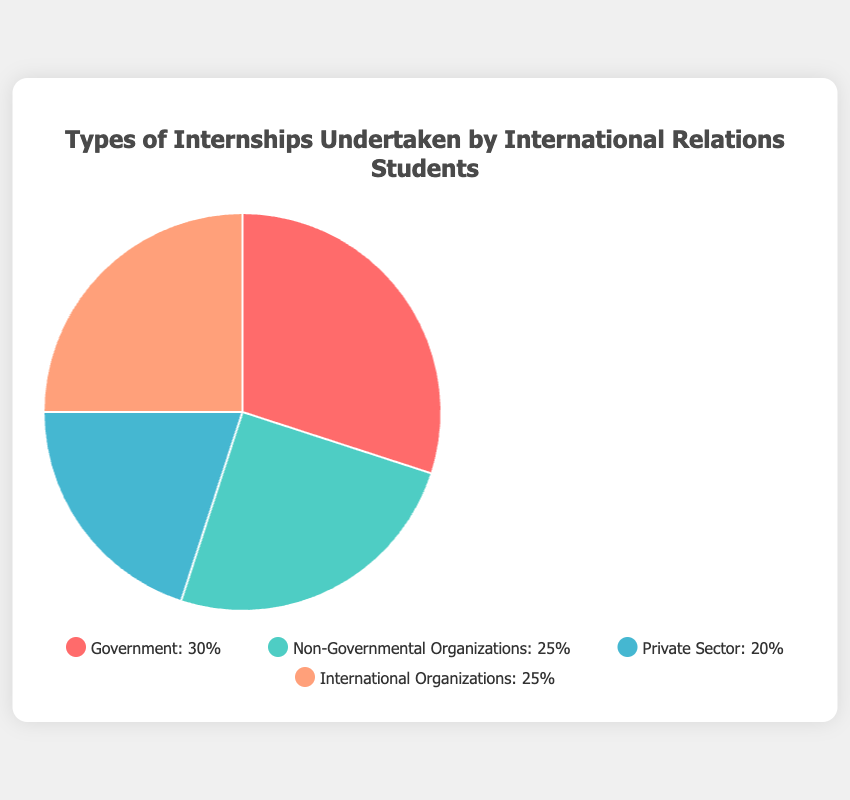What sector has the highest percentage of internships? The chart shows four sectors with their corresponding percentages. The Government sector has the highest percentage at 30%.
Answer: Government Which sectors have an equal percentage of internships? By looking at the chart, we can see that Non-Governmental Organizations and International Organizations both have 25%.
Answer: Non-Governmental Organizations, International Organizations What is the total percentage of internships for Government and Private Sector combined? The Government sector has 30% and the Private Sector has 20%. Adding them gives us 30% + 20% = 50%.
Answer: 50% Which sector has the lowest percentage of internships and what is that percentage? Examining the chart, we see that the Private Sector has the lowest percentage at 20%.
Answer: Private Sector, 20% How does the percentage of Non-Governmental Organizations compare to the Private Sector? The chart shows that Non-Governmental Organizations have 25% and the Private Sector has 20%. 25% is greater than 20%.
Answer: Non-Governmental Organizations have a higher percentage Are the percentages for Non-Governmental Organizations and International Organizations the same? Looking at the chart, both sectors show a percentage of 25%.
Answer: Yes What is the difference in percentage between the sector with the highest internships and the sector with the lowest internships? The Government sector has the highest internship percentage at 30%, and the Private Sector has the lowest at 20%. The difference is 30% - 20% = 10%.
Answer: 10% If you were to average the percentages of all four sectors, what would that average be? Adding the percentages: 30% (Government) + 25% (Non-Governmental Organizations) + 20% (Private Sector) + 25% (International Organizations) = 100%. The average is 100% / 4 sectors ≈ 25%.
Answer: 25% What color represents the Private Sector in the pie chart? By examining the chart, the Private Sector portion is shown in blue.
Answer: Blue What is the percentage difference between Government internships and International Organizations? The chart shows that Government internships are at 30%, and International Organizations are at 25%. The difference is 30% - 25% = 5%.
Answer: 5% 